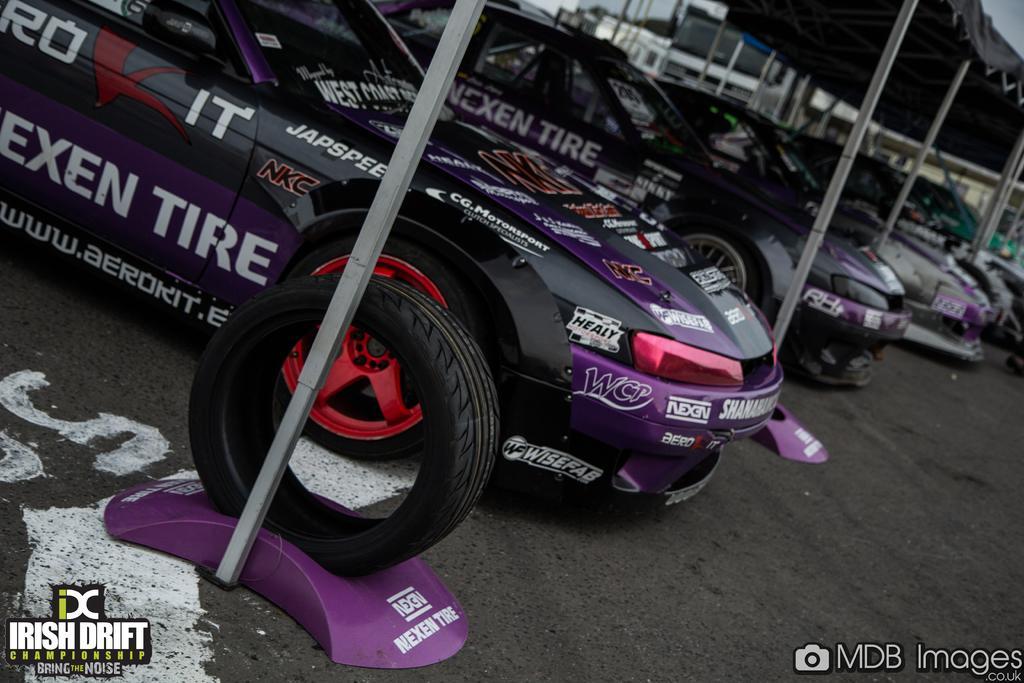Can you describe this image briefly? In this image we can see sports cars placed in a row. In the background there is a tent. At the bottom we can see a road. 